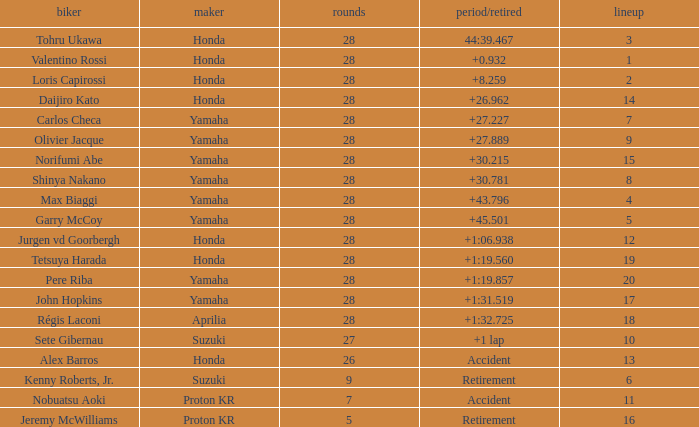How many laps did pere riba ride? 28.0. 